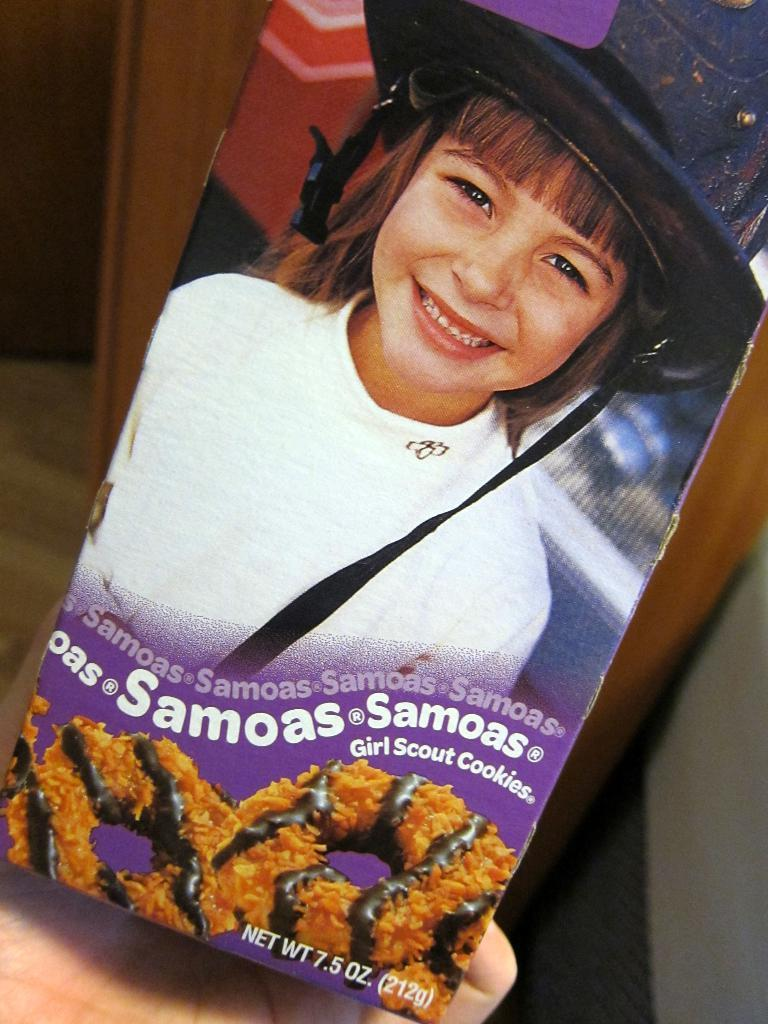What part of a person can be seen in the image? There is a person's hand in the image. What is depicted on the poster in the image? There is a poster with a child smiling in the image. What type of food is present in the image? There is food in the image. What can be found on the food in the image? The food has text on it. What can be seen in the background of the image? There are objects visible in the background of the image. What type of jeans is the person wearing in the image? There is no information about the person's clothing in the image, so we cannot determine if they are wearing jeans or any other type of garment. What impulse caused the person to create the text on the food in the image? The image does not provide any information about the person's motivations or intentions, so we cannot determine the impulse behind the text on the food. 